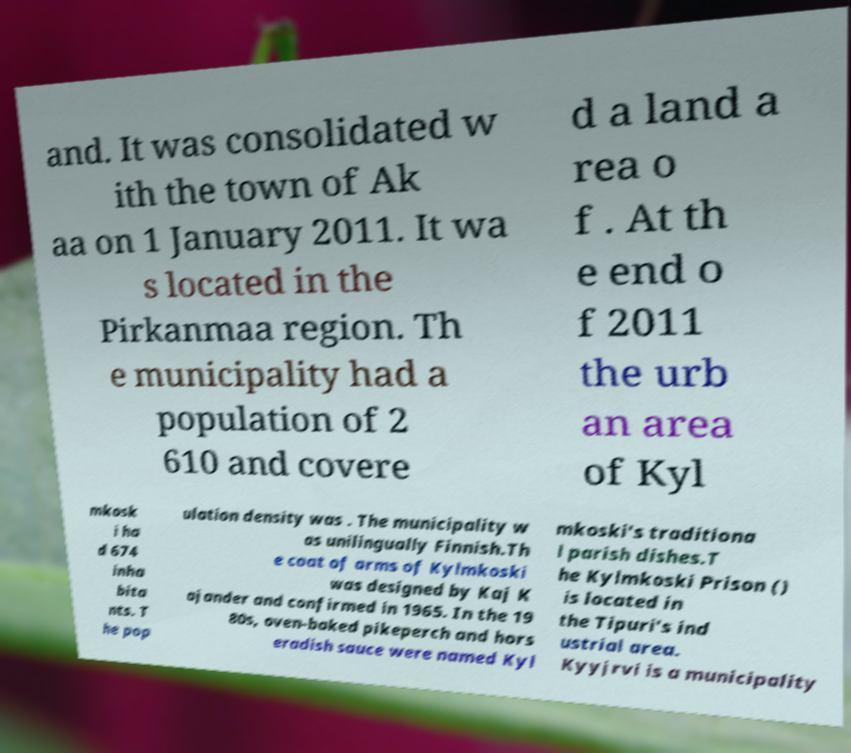What messages or text are displayed in this image? I need them in a readable, typed format. and. It was consolidated w ith the town of Ak aa on 1 January 2011. It wa s located in the Pirkanmaa region. Th e municipality had a population of 2 610 and covere d a land a rea o f . At th e end o f 2011 the urb an area of Kyl mkosk i ha d 674 inha bita nts. T he pop ulation density was . The municipality w as unilingually Finnish.Th e coat of arms of Kylmkoski was designed by Kaj K ajander and confirmed in 1965. In the 19 80s, oven-baked pikeperch and hors eradish sauce were named Kyl mkoski's traditiona l parish dishes.T he Kylmkoski Prison () is located in the Tipuri's ind ustrial area. Kyyjrvi is a municipality 